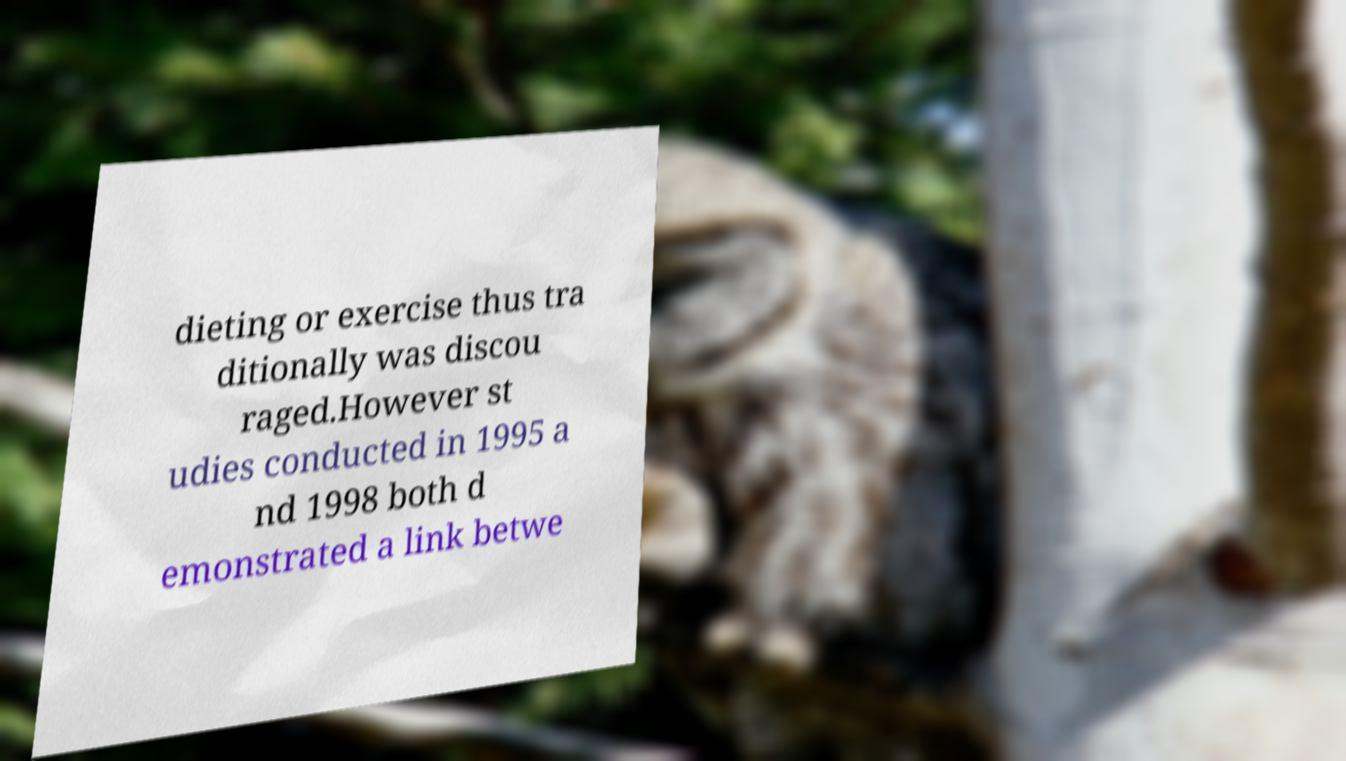Please read and relay the text visible in this image. What does it say? dieting or exercise thus tra ditionally was discou raged.However st udies conducted in 1995 a nd 1998 both d emonstrated a link betwe 